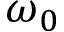<formula> <loc_0><loc_0><loc_500><loc_500>\omega _ { 0 }</formula> 